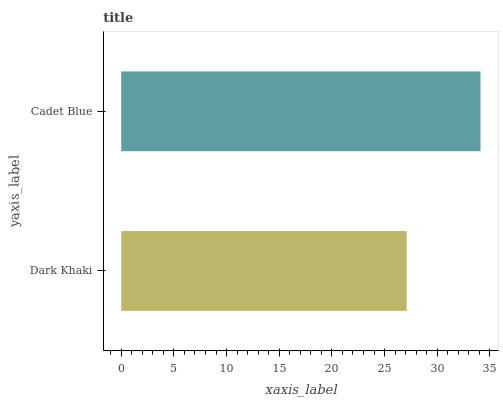Is Dark Khaki the minimum?
Answer yes or no. Yes. Is Cadet Blue the maximum?
Answer yes or no. Yes. Is Cadet Blue the minimum?
Answer yes or no. No. Is Cadet Blue greater than Dark Khaki?
Answer yes or no. Yes. Is Dark Khaki less than Cadet Blue?
Answer yes or no. Yes. Is Dark Khaki greater than Cadet Blue?
Answer yes or no. No. Is Cadet Blue less than Dark Khaki?
Answer yes or no. No. Is Cadet Blue the high median?
Answer yes or no. Yes. Is Dark Khaki the low median?
Answer yes or no. Yes. Is Dark Khaki the high median?
Answer yes or no. No. Is Cadet Blue the low median?
Answer yes or no. No. 